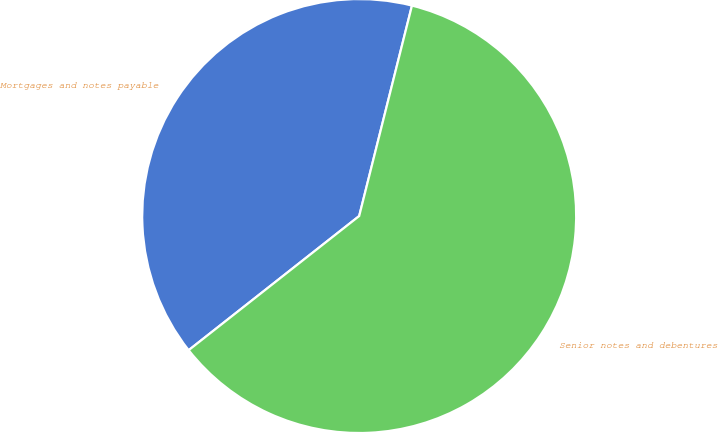Convert chart to OTSL. <chart><loc_0><loc_0><loc_500><loc_500><pie_chart><fcel>Mortgages and notes payable<fcel>Senior notes and debentures<nl><fcel>39.52%<fcel>60.48%<nl></chart> 